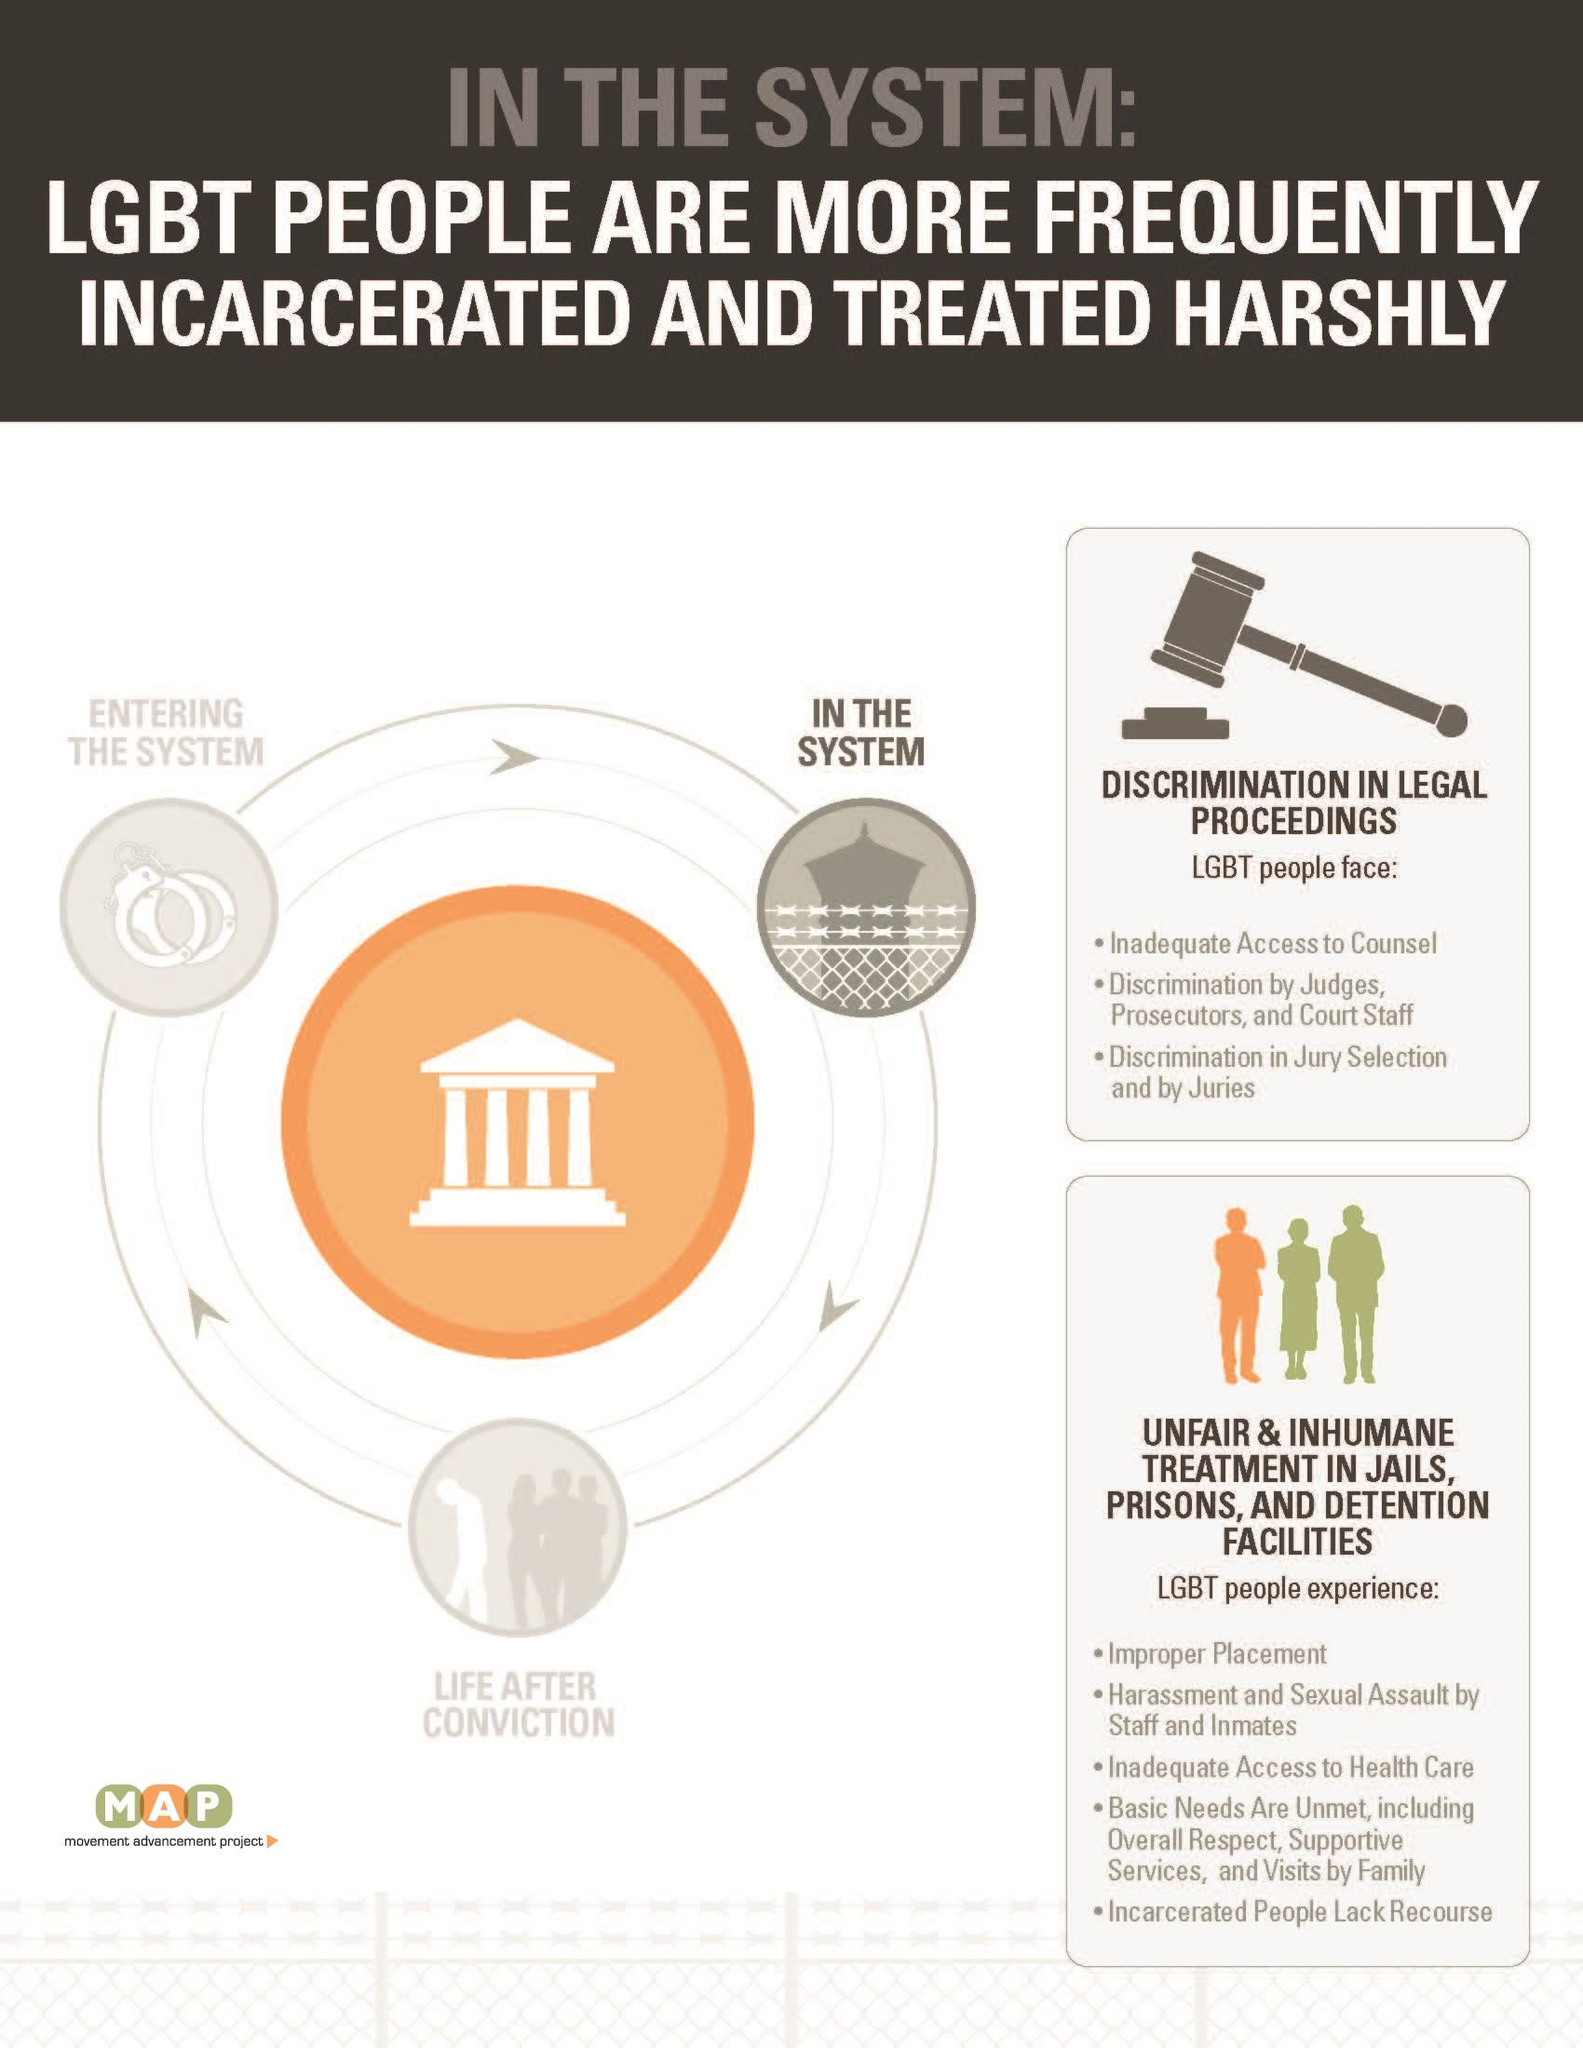List a handful of essential elements in this visual. LGBT individuals face discrimination by juries. Inadequate access to health care is the third difficulty faced by LGBT people in prisons. Discrimination in jury selection and by juries is the third challenge faced by LGBT individuals in legal proceedings. The first challenge faced by LGBT individuals in legal proceedings is inadequate access to legal counsel. LGBT individuals in prison are subjected to harassment and sexual assault by both staff members and inmates. 